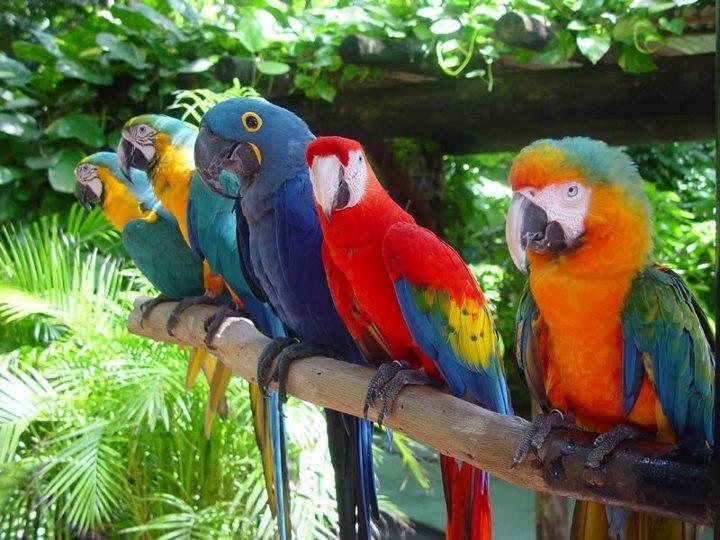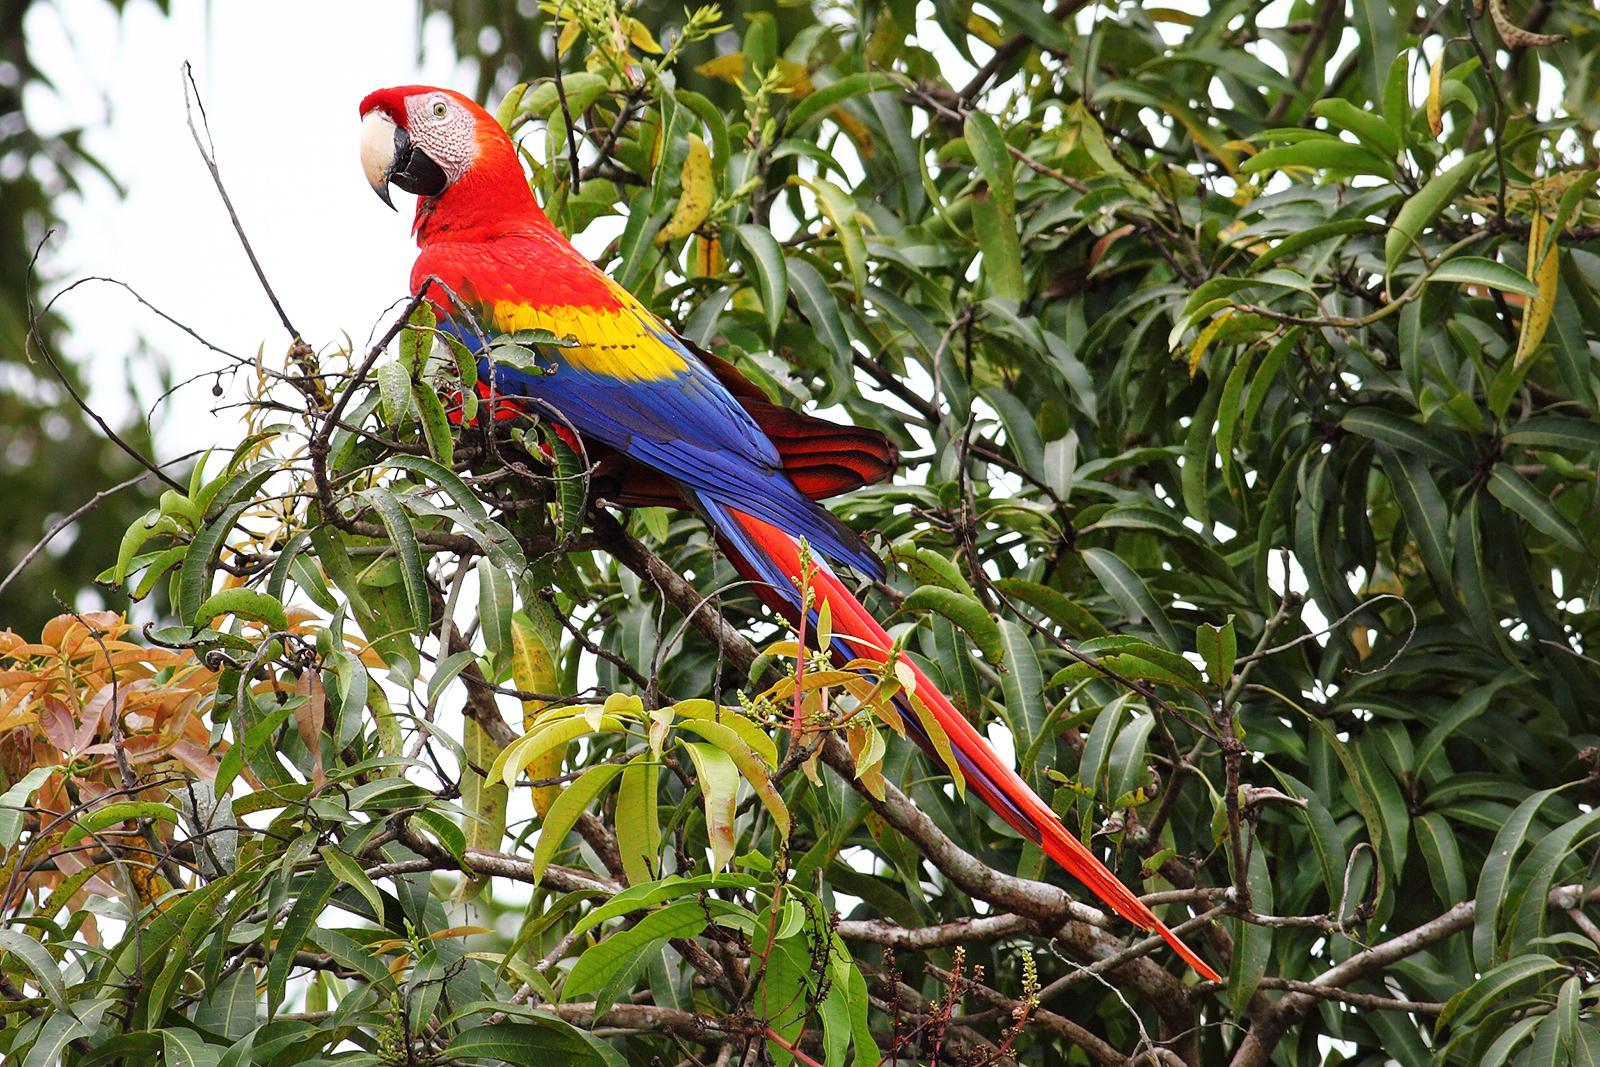The first image is the image on the left, the second image is the image on the right. Given the left and right images, does the statement "there are many birds perched on the side of a cliff in one of the images." hold true? Answer yes or no. No. The first image is the image on the left, the second image is the image on the right. For the images shown, is this caption "In one image, parrots are shown with a tall ice cream dessert." true? Answer yes or no. No. 